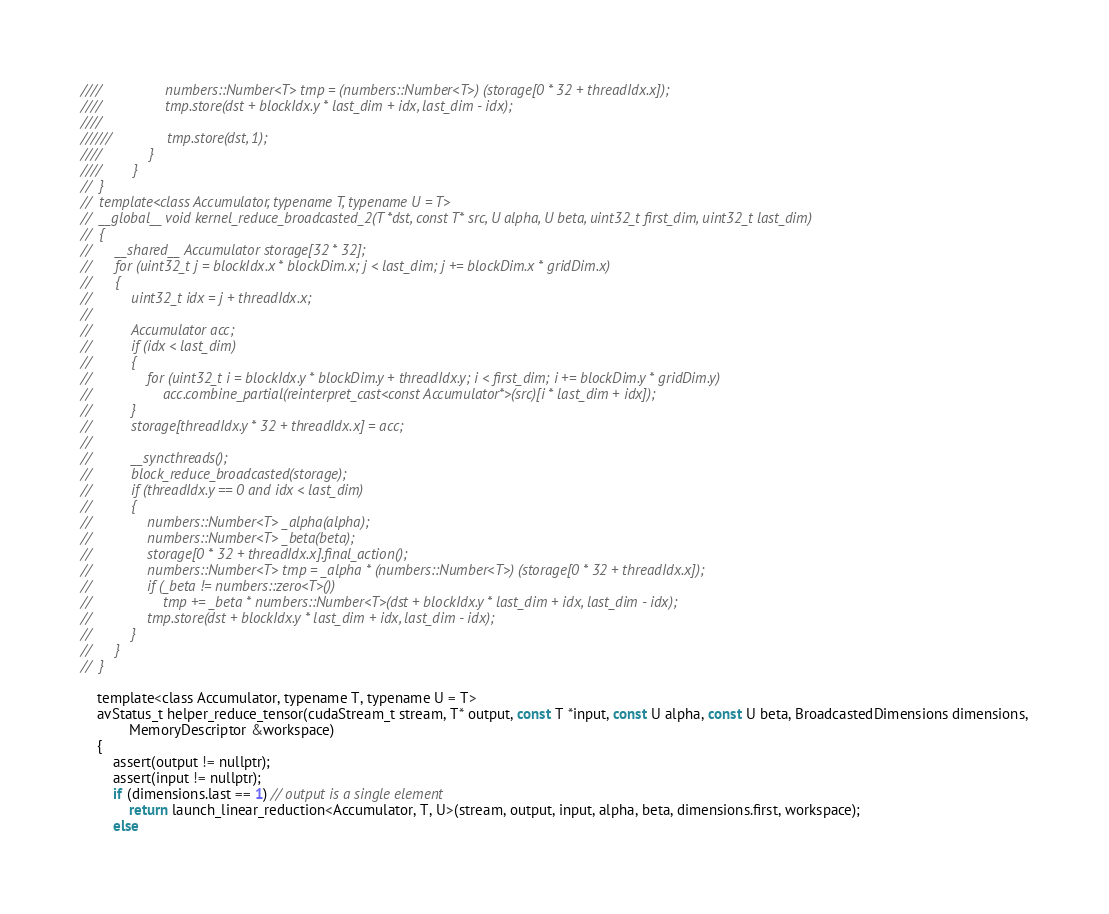<code> <loc_0><loc_0><loc_500><loc_500><_Cuda_>////				numbers::Number<T> tmp = (numbers::Number<T>) (storage[0 * 32 + threadIdx.x]);
////				tmp.store(dst + blockIdx.y * last_dim + idx, last_dim - idx);
////
//////				tmp.store(dst, 1);
////			}
////		}
//	}
//	template<class Accumulator, typename T, typename U = T>
//	__global__ void kernel_reduce_broadcasted_2(T *dst, const T* src, U alpha, U beta, uint32_t first_dim, uint32_t last_dim)
//	{
//		__shared__ Accumulator storage[32 * 32];
//		for (uint32_t j = blockIdx.x * blockDim.x; j < last_dim; j += blockDim.x * gridDim.x)
//		{
//			uint32_t idx = j + threadIdx.x;
//
//			Accumulator acc;
//			if (idx < last_dim)
//			{
//				for (uint32_t i = blockIdx.y * blockDim.y + threadIdx.y; i < first_dim; i += blockDim.y * gridDim.y)
//					acc.combine_partial(reinterpret_cast<const Accumulator*>(src)[i * last_dim + idx]);
//			}
//			storage[threadIdx.y * 32 + threadIdx.x] = acc;
//
//			__syncthreads();
//			block_reduce_broadcasted(storage);
//			if (threadIdx.y == 0 and idx < last_dim)
//			{
//				numbers::Number<T> _alpha(alpha);
//				numbers::Number<T> _beta(beta);
//				storage[0 * 32 + threadIdx.x].final_action();
//				numbers::Number<T> tmp = _alpha * (numbers::Number<T>) (storage[0 * 32 + threadIdx.x]);
//				if (_beta != numbers::zero<T>())
//					tmp += _beta * numbers::Number<T>(dst + blockIdx.y * last_dim + idx, last_dim - idx);
//				tmp.store(dst + blockIdx.y * last_dim + idx, last_dim - idx);
//			}
//		}
//	}

	template<class Accumulator, typename T, typename U = T>
	avStatus_t helper_reduce_tensor(cudaStream_t stream, T* output, const T *input, const U alpha, const U beta, BroadcastedDimensions dimensions,
			MemoryDescriptor &workspace)
	{
		assert(output != nullptr);
		assert(input != nullptr);
		if (dimensions.last == 1) // output is a single element
			return launch_linear_reduction<Accumulator, T, U>(stream, output, input, alpha, beta, dimensions.first, workspace);
		else</code> 